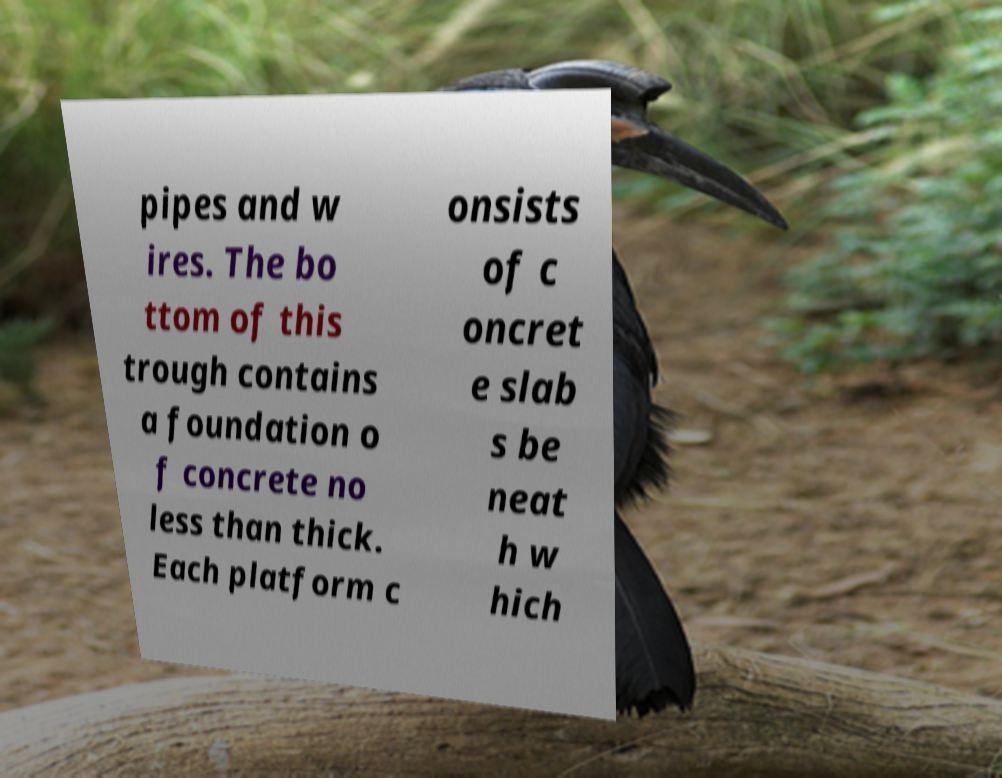Could you extract and type out the text from this image? pipes and w ires. The bo ttom of this trough contains a foundation o f concrete no less than thick. Each platform c onsists of c oncret e slab s be neat h w hich 